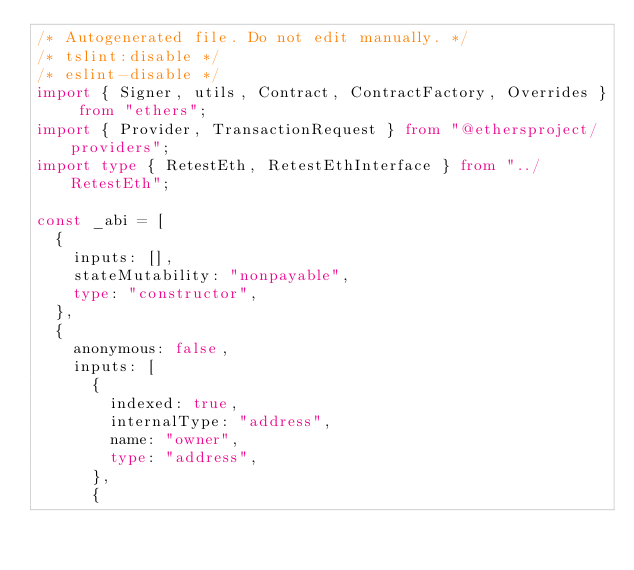<code> <loc_0><loc_0><loc_500><loc_500><_TypeScript_>/* Autogenerated file. Do not edit manually. */
/* tslint:disable */
/* eslint-disable */
import { Signer, utils, Contract, ContractFactory, Overrides } from "ethers";
import { Provider, TransactionRequest } from "@ethersproject/providers";
import type { RetestEth, RetestEthInterface } from "../RetestEth";

const _abi = [
  {
    inputs: [],
    stateMutability: "nonpayable",
    type: "constructor",
  },
  {
    anonymous: false,
    inputs: [
      {
        indexed: true,
        internalType: "address",
        name: "owner",
        type: "address",
      },
      {</code> 